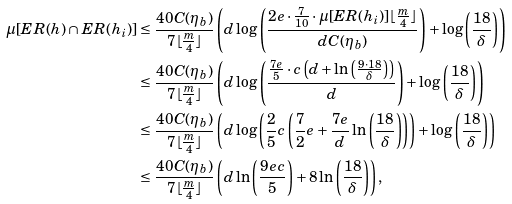Convert formula to latex. <formula><loc_0><loc_0><loc_500><loc_500>\mu [ E R ( h ) \cap E R ( h _ { i } ) ] & \leq \frac { 4 0 C ( \eta _ { b } ) } { 7 \lfloor \frac { m } { 4 } \rfloor } \left ( d \log \left ( \frac { 2 e \cdot \frac { 7 } { 1 0 } \cdot \mu [ E R ( h _ { i } ) ] \lfloor \frac { m } { 4 } \rfloor } { d C ( \eta _ { b } ) } \right ) + \log \left ( \frac { 1 8 } { \delta } \right ) \right ) \\ & \leq \frac { 4 0 C ( \eta _ { b } ) } { 7 \lfloor \frac { m } { 4 } \rfloor } \left ( d \log \left ( \frac { \frac { 7 e } { 5 } \cdot c \left ( d + \ln \left ( \frac { 9 \cdot 1 8 } { \delta } \right ) \right ) } { d } \right ) + \log \left ( \frac { 1 8 } { \delta } \right ) \right ) \\ & \leq \frac { 4 0 C ( \eta _ { b } ) } { 7 \lfloor \frac { m } { 4 } \rfloor } \left ( d \log \left ( \frac { 2 } { 5 } c \left ( \frac { 7 } { 2 } e + \frac { 7 e } { d } \ln \left ( \frac { 1 8 } { \delta } \right ) \right ) \right ) + \log \left ( \frac { 1 8 } { \delta } \right ) \right ) \\ & \leq \frac { 4 0 C ( \eta _ { b } ) } { 7 \lfloor \frac { m } { 4 } \rfloor } \left ( d \ln \left ( \frac { 9 e c } { 5 } \right ) + 8 \ln \left ( \frac { 1 8 } { \delta } \right ) \right ) ,</formula> 